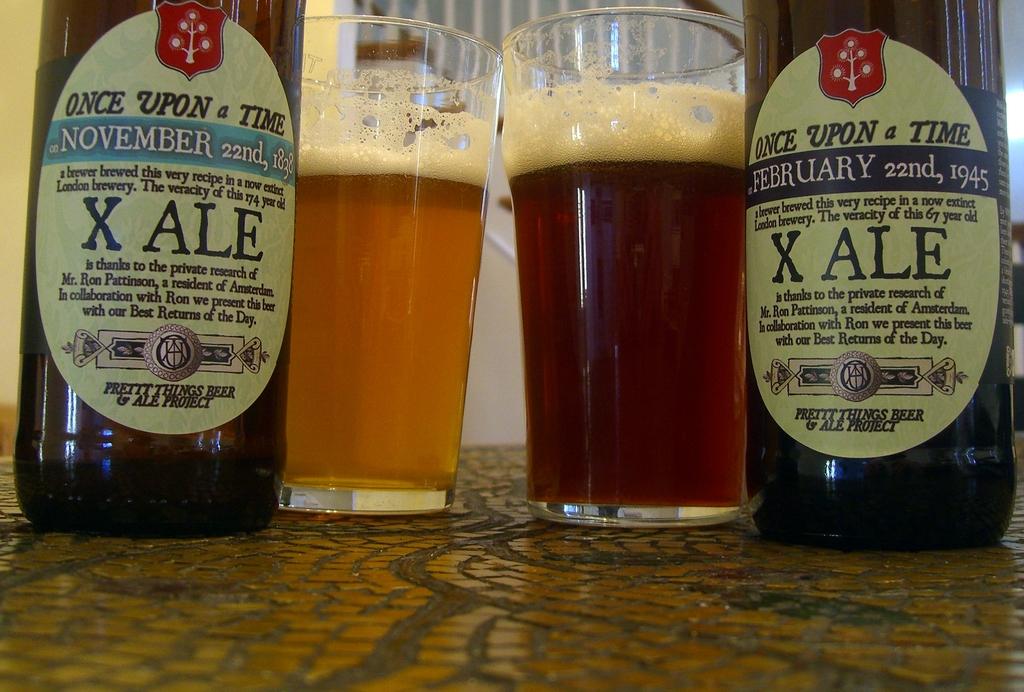What is the date on the bottle on the left?
Provide a succinct answer. November 22nd, 1832. 